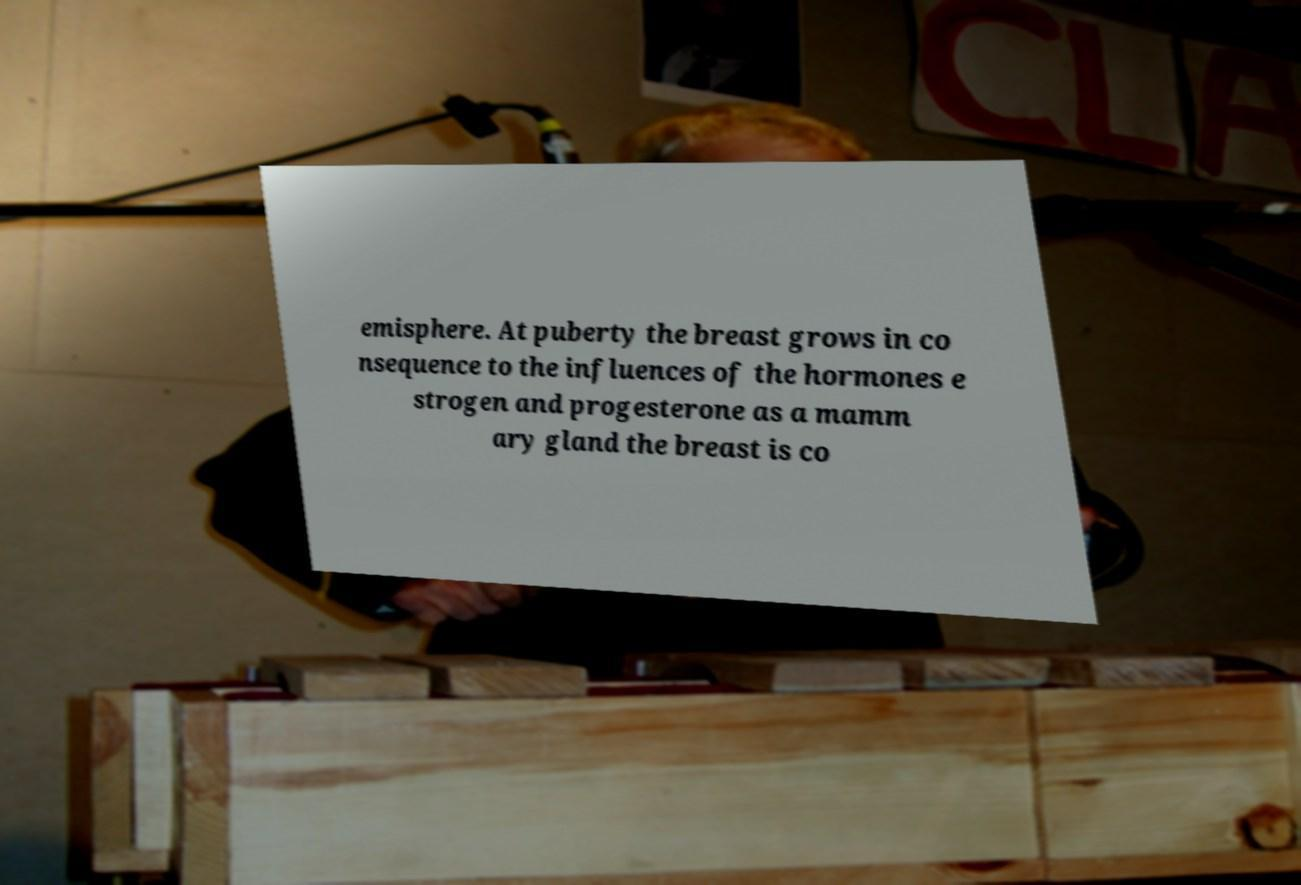Could you extract and type out the text from this image? emisphere. At puberty the breast grows in co nsequence to the influences of the hormones e strogen and progesterone as a mamm ary gland the breast is co 